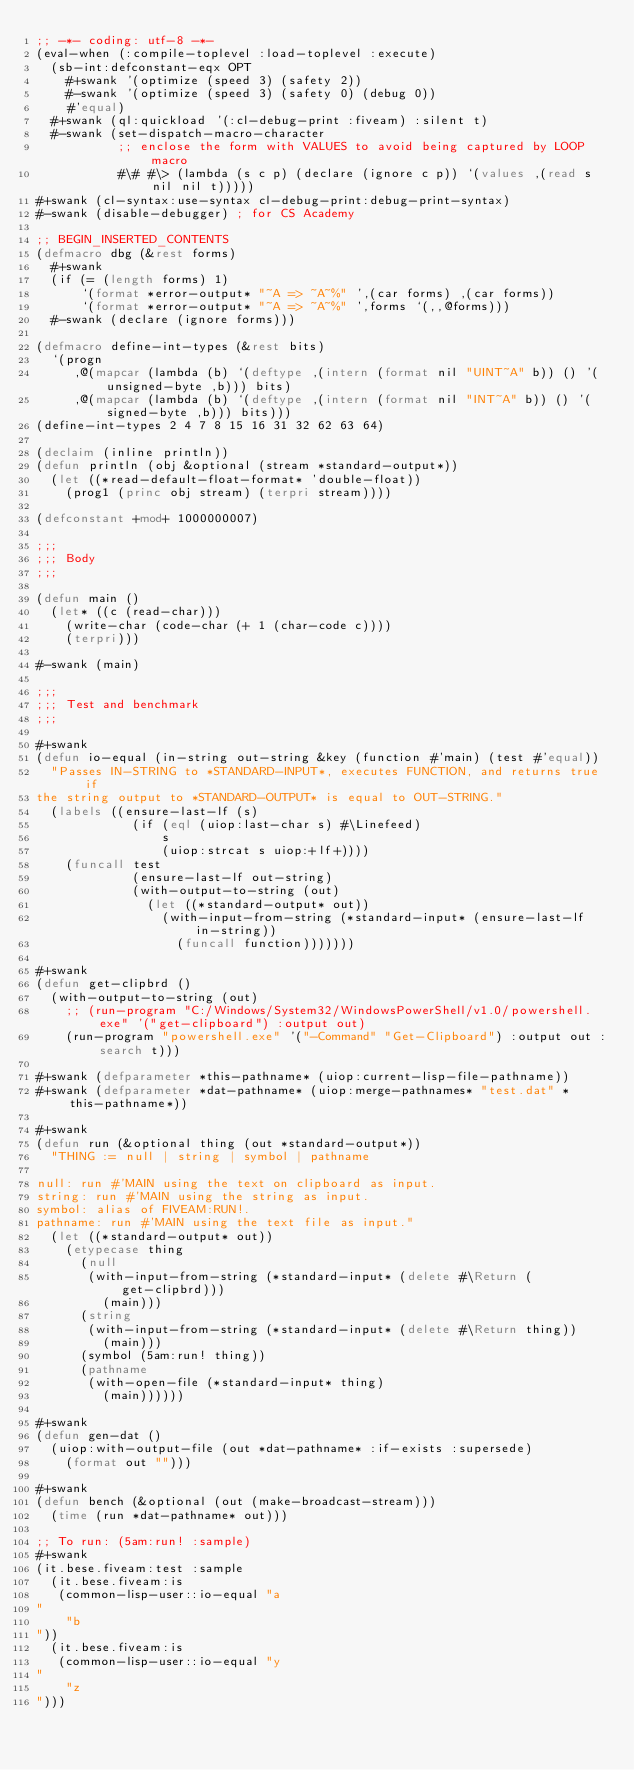<code> <loc_0><loc_0><loc_500><loc_500><_Lisp_>;; -*- coding: utf-8 -*-
(eval-when (:compile-toplevel :load-toplevel :execute)
  (sb-int:defconstant-eqx OPT
    #+swank '(optimize (speed 3) (safety 2))
    #-swank '(optimize (speed 3) (safety 0) (debug 0))
    #'equal)
  #+swank (ql:quickload '(:cl-debug-print :fiveam) :silent t)
  #-swank (set-dispatch-macro-character
           ;; enclose the form with VALUES to avoid being captured by LOOP macro
           #\# #\> (lambda (s c p) (declare (ignore c p)) `(values ,(read s nil nil t)))))
#+swank (cl-syntax:use-syntax cl-debug-print:debug-print-syntax)
#-swank (disable-debugger) ; for CS Academy

;; BEGIN_INSERTED_CONTENTS
(defmacro dbg (&rest forms)
  #+swank
  (if (= (length forms) 1)
      `(format *error-output* "~A => ~A~%" ',(car forms) ,(car forms))
      `(format *error-output* "~A => ~A~%" ',forms `(,,@forms)))
  #-swank (declare (ignore forms)))

(defmacro define-int-types (&rest bits)
  `(progn
     ,@(mapcar (lambda (b) `(deftype ,(intern (format nil "UINT~A" b)) () '(unsigned-byte ,b))) bits)
     ,@(mapcar (lambda (b) `(deftype ,(intern (format nil "INT~A" b)) () '(signed-byte ,b))) bits)))
(define-int-types 2 4 7 8 15 16 31 32 62 63 64)

(declaim (inline println))
(defun println (obj &optional (stream *standard-output*))
  (let ((*read-default-float-format* 'double-float))
    (prog1 (princ obj stream) (terpri stream))))

(defconstant +mod+ 1000000007)

;;;
;;; Body
;;;

(defun main ()
  (let* ((c (read-char)))
    (write-char (code-char (+ 1 (char-code c))))
    (terpri)))

#-swank (main)

;;;
;;; Test and benchmark
;;;

#+swank
(defun io-equal (in-string out-string &key (function #'main) (test #'equal))
  "Passes IN-STRING to *STANDARD-INPUT*, executes FUNCTION, and returns true if
the string output to *STANDARD-OUTPUT* is equal to OUT-STRING."
  (labels ((ensure-last-lf (s)
             (if (eql (uiop:last-char s) #\Linefeed)
                 s
                 (uiop:strcat s uiop:+lf+))))
    (funcall test
             (ensure-last-lf out-string)
             (with-output-to-string (out)
               (let ((*standard-output* out))
                 (with-input-from-string (*standard-input* (ensure-last-lf in-string))
                   (funcall function)))))))

#+swank
(defun get-clipbrd ()
  (with-output-to-string (out)
    ;; (run-program "C:/Windows/System32/WindowsPowerShell/v1.0/powershell.exe" '("get-clipboard") :output out)
    (run-program "powershell.exe" '("-Command" "Get-Clipboard") :output out :search t)))

#+swank (defparameter *this-pathname* (uiop:current-lisp-file-pathname))
#+swank (defparameter *dat-pathname* (uiop:merge-pathnames* "test.dat" *this-pathname*))

#+swank
(defun run (&optional thing (out *standard-output*))
  "THING := null | string | symbol | pathname

null: run #'MAIN using the text on clipboard as input.
string: run #'MAIN using the string as input.
symbol: alias of FIVEAM:RUN!.
pathname: run #'MAIN using the text file as input."
  (let ((*standard-output* out))
    (etypecase thing
      (null
       (with-input-from-string (*standard-input* (delete #\Return (get-clipbrd)))
         (main)))
      (string
       (with-input-from-string (*standard-input* (delete #\Return thing))
         (main)))
      (symbol (5am:run! thing))
      (pathname
       (with-open-file (*standard-input* thing)
         (main))))))

#+swank
(defun gen-dat ()
  (uiop:with-output-file (out *dat-pathname* :if-exists :supersede)
    (format out "")))

#+swank
(defun bench (&optional (out (make-broadcast-stream)))
  (time (run *dat-pathname* out)))

;; To run: (5am:run! :sample)
#+swank
(it.bese.fiveam:test :sample
  (it.bese.fiveam:is
   (common-lisp-user::io-equal "a
"
    "b
"))
  (it.bese.fiveam:is
   (common-lisp-user::io-equal "y
"
    "z
")))
</code> 